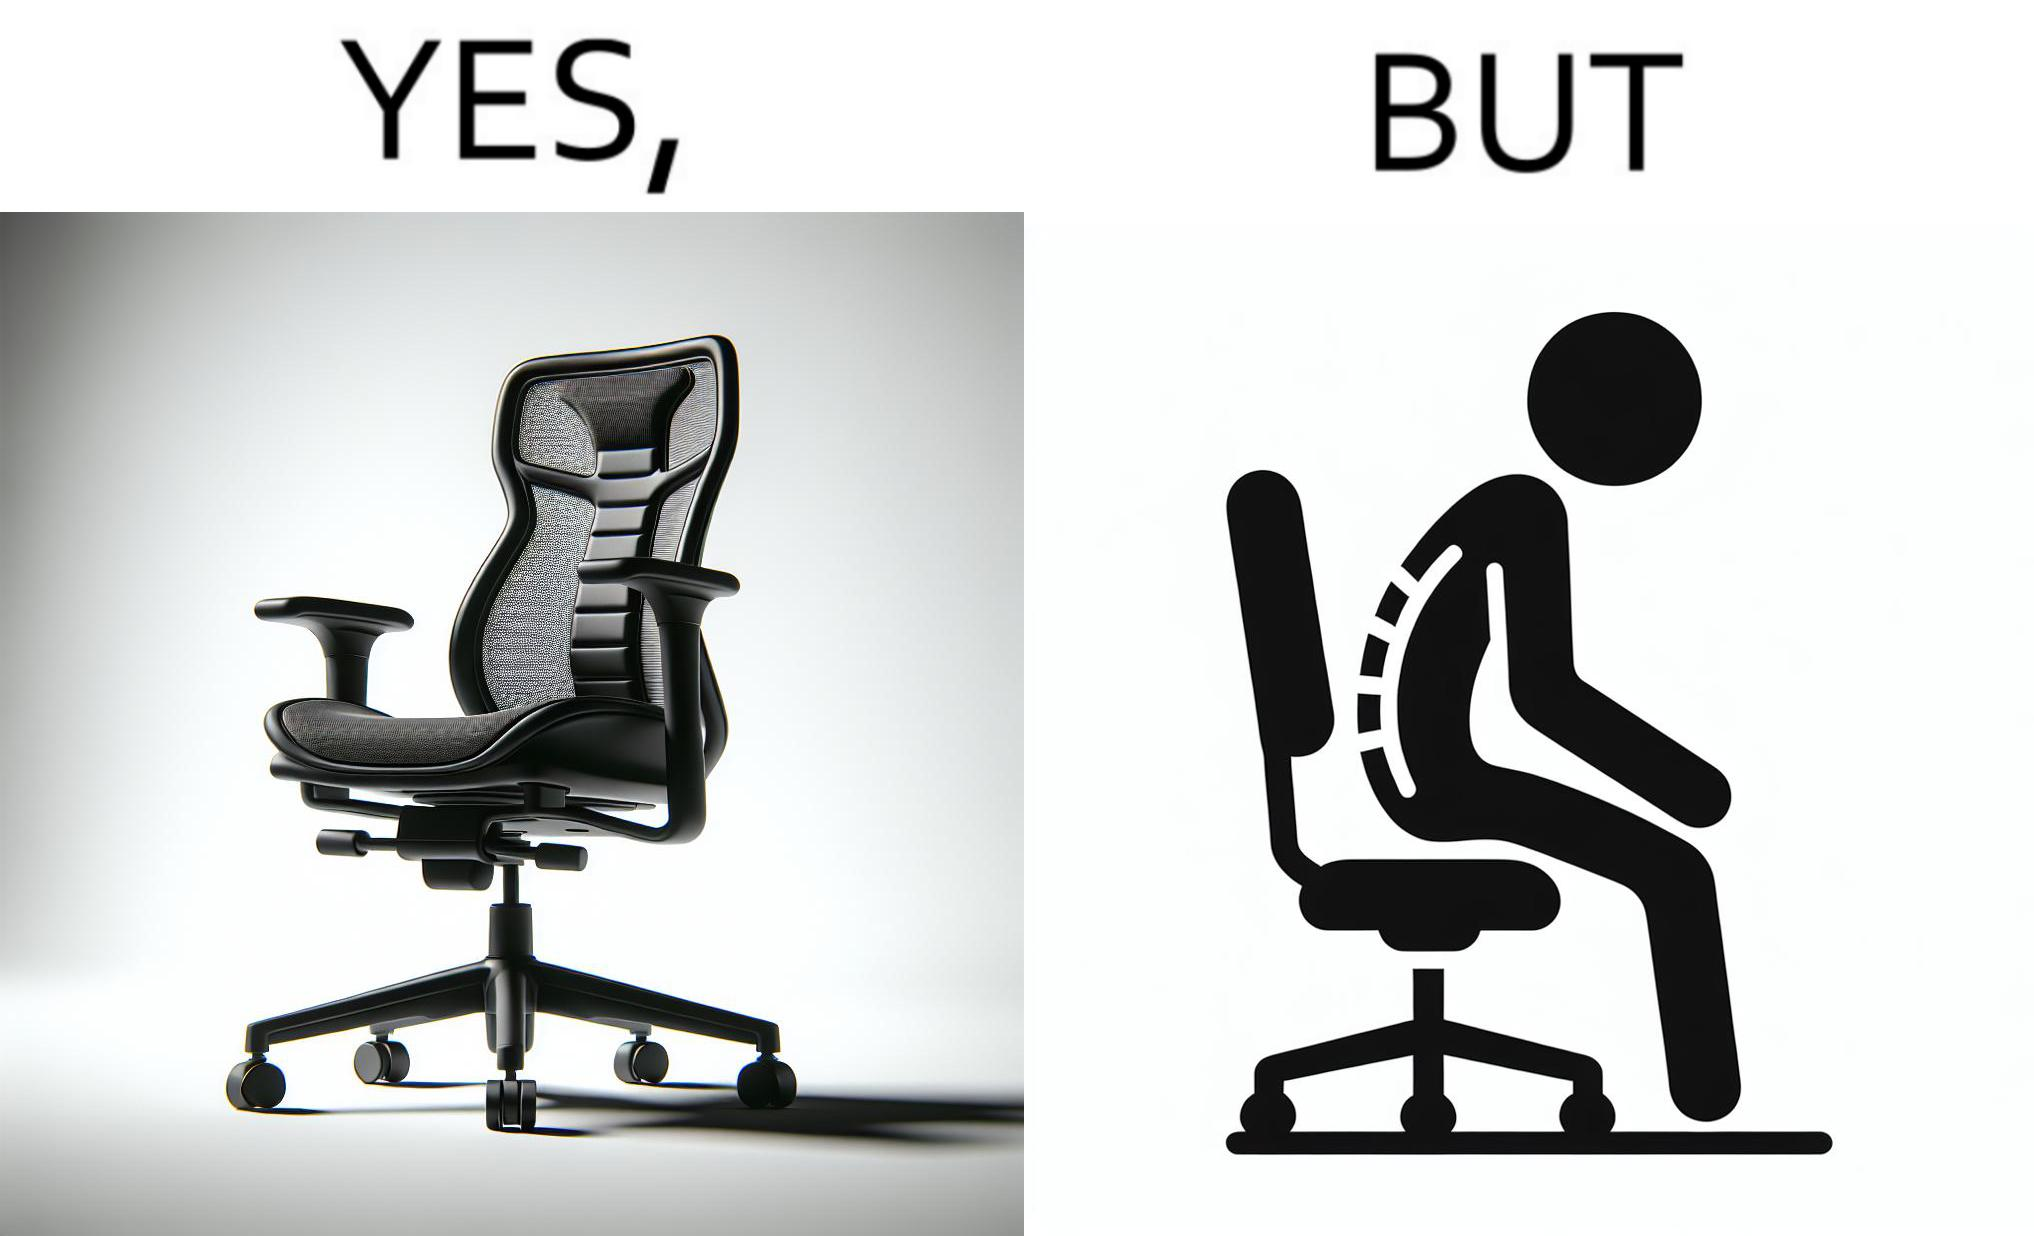What does this image depict? The image is ironical, as even though the ergonomic chair is meant to facilitate an upright and comfortable posture for the person sitting on it, the person sitting on it still has a bent posture, as the person is not utilizing the backrest. 